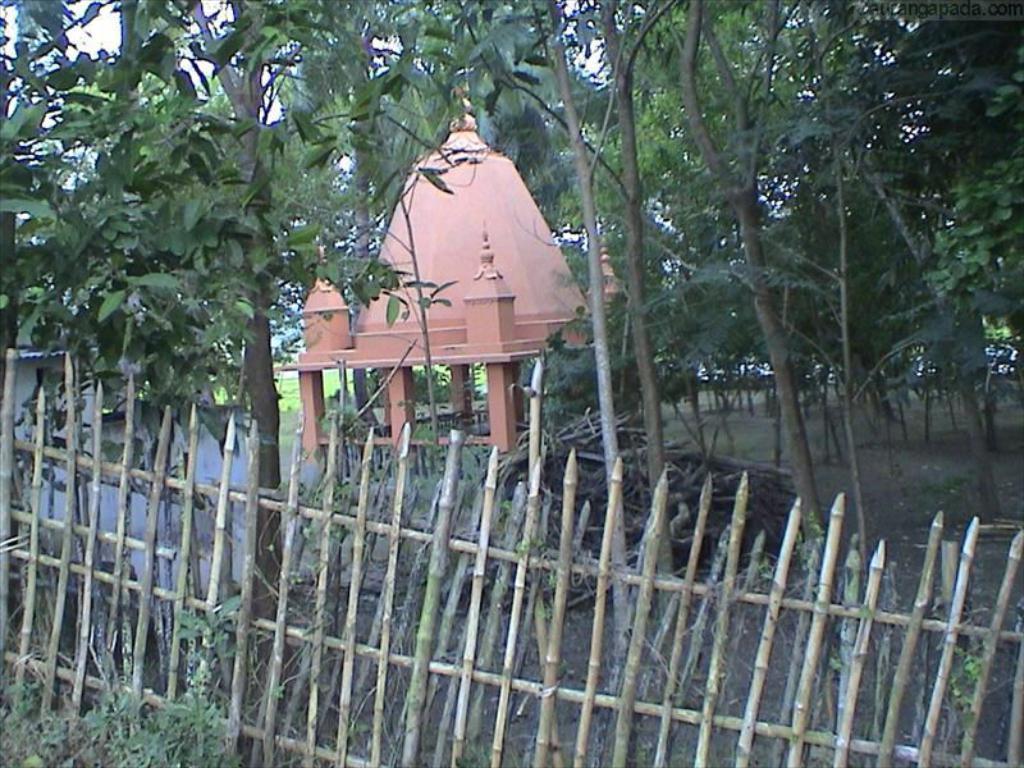Describe this image in one or two sentences. In this image there is a wooden railing, in the background there are trees and a shelter. 